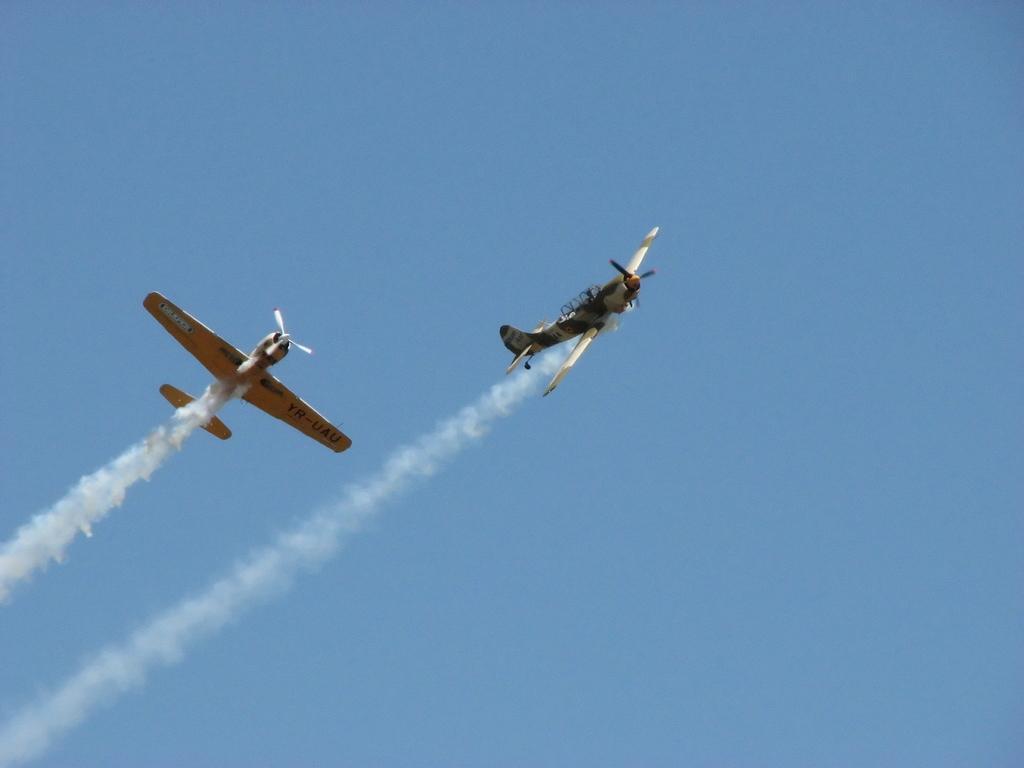Could you give a brief overview of what you see in this image? In this image there are two airplanes in the sky. 